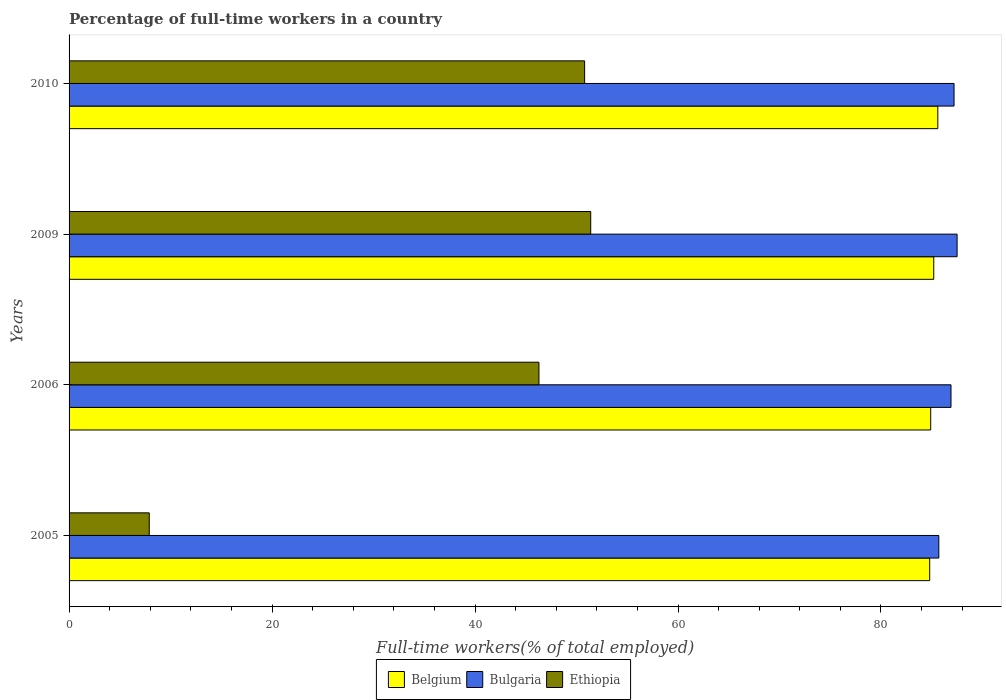Are the number of bars on each tick of the Y-axis equal?
Provide a succinct answer. Yes. How many bars are there on the 4th tick from the top?
Offer a very short reply. 3. What is the label of the 4th group of bars from the top?
Ensure brevity in your answer.  2005. What is the percentage of full-time workers in Bulgaria in 2009?
Your answer should be very brief. 87.5. Across all years, what is the maximum percentage of full-time workers in Ethiopia?
Offer a very short reply. 51.4. Across all years, what is the minimum percentage of full-time workers in Belgium?
Offer a terse response. 84.8. What is the total percentage of full-time workers in Belgium in the graph?
Offer a very short reply. 340.5. What is the difference between the percentage of full-time workers in Bulgaria in 2005 and that in 2006?
Ensure brevity in your answer.  -1.2. What is the difference between the percentage of full-time workers in Bulgaria in 2006 and the percentage of full-time workers in Ethiopia in 2005?
Provide a short and direct response. 79. What is the average percentage of full-time workers in Belgium per year?
Give a very brief answer. 85.12. In the year 2005, what is the difference between the percentage of full-time workers in Bulgaria and percentage of full-time workers in Ethiopia?
Provide a short and direct response. 77.8. What is the ratio of the percentage of full-time workers in Ethiopia in 2009 to that in 2010?
Provide a short and direct response. 1.01. Is the percentage of full-time workers in Ethiopia in 2005 less than that in 2006?
Offer a terse response. Yes. Is the difference between the percentage of full-time workers in Bulgaria in 2005 and 2010 greater than the difference between the percentage of full-time workers in Ethiopia in 2005 and 2010?
Give a very brief answer. Yes. What is the difference between the highest and the second highest percentage of full-time workers in Belgium?
Offer a very short reply. 0.4. What is the difference between the highest and the lowest percentage of full-time workers in Ethiopia?
Offer a very short reply. 43.5. In how many years, is the percentage of full-time workers in Bulgaria greater than the average percentage of full-time workers in Bulgaria taken over all years?
Ensure brevity in your answer.  3. Is the sum of the percentage of full-time workers in Ethiopia in 2005 and 2009 greater than the maximum percentage of full-time workers in Belgium across all years?
Offer a very short reply. No. What does the 2nd bar from the top in 2010 represents?
Your answer should be very brief. Bulgaria. What does the 3rd bar from the bottom in 2010 represents?
Ensure brevity in your answer.  Ethiopia. How many bars are there?
Your answer should be compact. 12. Are all the bars in the graph horizontal?
Provide a succinct answer. Yes. What is the difference between two consecutive major ticks on the X-axis?
Provide a short and direct response. 20. Where does the legend appear in the graph?
Offer a terse response. Bottom center. How are the legend labels stacked?
Your answer should be compact. Horizontal. What is the title of the graph?
Offer a very short reply. Percentage of full-time workers in a country. Does "European Union" appear as one of the legend labels in the graph?
Offer a very short reply. No. What is the label or title of the X-axis?
Provide a short and direct response. Full-time workers(% of total employed). What is the label or title of the Y-axis?
Make the answer very short. Years. What is the Full-time workers(% of total employed) in Belgium in 2005?
Keep it short and to the point. 84.8. What is the Full-time workers(% of total employed) in Bulgaria in 2005?
Provide a short and direct response. 85.7. What is the Full-time workers(% of total employed) of Ethiopia in 2005?
Provide a succinct answer. 7.9. What is the Full-time workers(% of total employed) in Belgium in 2006?
Ensure brevity in your answer.  84.9. What is the Full-time workers(% of total employed) in Bulgaria in 2006?
Offer a terse response. 86.9. What is the Full-time workers(% of total employed) of Ethiopia in 2006?
Provide a short and direct response. 46.3. What is the Full-time workers(% of total employed) of Belgium in 2009?
Offer a very short reply. 85.2. What is the Full-time workers(% of total employed) of Bulgaria in 2009?
Offer a very short reply. 87.5. What is the Full-time workers(% of total employed) in Ethiopia in 2009?
Your response must be concise. 51.4. What is the Full-time workers(% of total employed) of Belgium in 2010?
Offer a very short reply. 85.6. What is the Full-time workers(% of total employed) of Bulgaria in 2010?
Your response must be concise. 87.2. What is the Full-time workers(% of total employed) in Ethiopia in 2010?
Keep it short and to the point. 50.8. Across all years, what is the maximum Full-time workers(% of total employed) in Belgium?
Offer a very short reply. 85.6. Across all years, what is the maximum Full-time workers(% of total employed) of Bulgaria?
Offer a terse response. 87.5. Across all years, what is the maximum Full-time workers(% of total employed) in Ethiopia?
Offer a very short reply. 51.4. Across all years, what is the minimum Full-time workers(% of total employed) of Belgium?
Provide a succinct answer. 84.8. Across all years, what is the minimum Full-time workers(% of total employed) of Bulgaria?
Ensure brevity in your answer.  85.7. Across all years, what is the minimum Full-time workers(% of total employed) in Ethiopia?
Offer a terse response. 7.9. What is the total Full-time workers(% of total employed) of Belgium in the graph?
Your answer should be very brief. 340.5. What is the total Full-time workers(% of total employed) of Bulgaria in the graph?
Your answer should be compact. 347.3. What is the total Full-time workers(% of total employed) of Ethiopia in the graph?
Give a very brief answer. 156.4. What is the difference between the Full-time workers(% of total employed) of Ethiopia in 2005 and that in 2006?
Provide a short and direct response. -38.4. What is the difference between the Full-time workers(% of total employed) in Belgium in 2005 and that in 2009?
Make the answer very short. -0.4. What is the difference between the Full-time workers(% of total employed) of Ethiopia in 2005 and that in 2009?
Your answer should be very brief. -43.5. What is the difference between the Full-time workers(% of total employed) in Bulgaria in 2005 and that in 2010?
Your response must be concise. -1.5. What is the difference between the Full-time workers(% of total employed) in Ethiopia in 2005 and that in 2010?
Ensure brevity in your answer.  -42.9. What is the difference between the Full-time workers(% of total employed) in Belgium in 2009 and that in 2010?
Make the answer very short. -0.4. What is the difference between the Full-time workers(% of total employed) in Ethiopia in 2009 and that in 2010?
Offer a very short reply. 0.6. What is the difference between the Full-time workers(% of total employed) of Belgium in 2005 and the Full-time workers(% of total employed) of Bulgaria in 2006?
Your answer should be very brief. -2.1. What is the difference between the Full-time workers(% of total employed) in Belgium in 2005 and the Full-time workers(% of total employed) in Ethiopia in 2006?
Keep it short and to the point. 38.5. What is the difference between the Full-time workers(% of total employed) of Bulgaria in 2005 and the Full-time workers(% of total employed) of Ethiopia in 2006?
Provide a short and direct response. 39.4. What is the difference between the Full-time workers(% of total employed) of Belgium in 2005 and the Full-time workers(% of total employed) of Bulgaria in 2009?
Your response must be concise. -2.7. What is the difference between the Full-time workers(% of total employed) of Belgium in 2005 and the Full-time workers(% of total employed) of Ethiopia in 2009?
Provide a succinct answer. 33.4. What is the difference between the Full-time workers(% of total employed) in Bulgaria in 2005 and the Full-time workers(% of total employed) in Ethiopia in 2009?
Your answer should be compact. 34.3. What is the difference between the Full-time workers(% of total employed) of Belgium in 2005 and the Full-time workers(% of total employed) of Ethiopia in 2010?
Keep it short and to the point. 34. What is the difference between the Full-time workers(% of total employed) in Bulgaria in 2005 and the Full-time workers(% of total employed) in Ethiopia in 2010?
Offer a very short reply. 34.9. What is the difference between the Full-time workers(% of total employed) in Belgium in 2006 and the Full-time workers(% of total employed) in Ethiopia in 2009?
Your response must be concise. 33.5. What is the difference between the Full-time workers(% of total employed) in Bulgaria in 2006 and the Full-time workers(% of total employed) in Ethiopia in 2009?
Make the answer very short. 35.5. What is the difference between the Full-time workers(% of total employed) of Belgium in 2006 and the Full-time workers(% of total employed) of Bulgaria in 2010?
Keep it short and to the point. -2.3. What is the difference between the Full-time workers(% of total employed) of Belgium in 2006 and the Full-time workers(% of total employed) of Ethiopia in 2010?
Give a very brief answer. 34.1. What is the difference between the Full-time workers(% of total employed) in Bulgaria in 2006 and the Full-time workers(% of total employed) in Ethiopia in 2010?
Your answer should be compact. 36.1. What is the difference between the Full-time workers(% of total employed) of Belgium in 2009 and the Full-time workers(% of total employed) of Ethiopia in 2010?
Provide a short and direct response. 34.4. What is the difference between the Full-time workers(% of total employed) of Bulgaria in 2009 and the Full-time workers(% of total employed) of Ethiopia in 2010?
Offer a very short reply. 36.7. What is the average Full-time workers(% of total employed) of Belgium per year?
Your answer should be compact. 85.12. What is the average Full-time workers(% of total employed) in Bulgaria per year?
Give a very brief answer. 86.83. What is the average Full-time workers(% of total employed) of Ethiopia per year?
Your answer should be very brief. 39.1. In the year 2005, what is the difference between the Full-time workers(% of total employed) in Belgium and Full-time workers(% of total employed) in Ethiopia?
Offer a terse response. 76.9. In the year 2005, what is the difference between the Full-time workers(% of total employed) of Bulgaria and Full-time workers(% of total employed) of Ethiopia?
Your answer should be compact. 77.8. In the year 2006, what is the difference between the Full-time workers(% of total employed) of Belgium and Full-time workers(% of total employed) of Bulgaria?
Ensure brevity in your answer.  -2. In the year 2006, what is the difference between the Full-time workers(% of total employed) of Belgium and Full-time workers(% of total employed) of Ethiopia?
Your response must be concise. 38.6. In the year 2006, what is the difference between the Full-time workers(% of total employed) in Bulgaria and Full-time workers(% of total employed) in Ethiopia?
Provide a short and direct response. 40.6. In the year 2009, what is the difference between the Full-time workers(% of total employed) in Belgium and Full-time workers(% of total employed) in Ethiopia?
Make the answer very short. 33.8. In the year 2009, what is the difference between the Full-time workers(% of total employed) in Bulgaria and Full-time workers(% of total employed) in Ethiopia?
Offer a very short reply. 36.1. In the year 2010, what is the difference between the Full-time workers(% of total employed) in Belgium and Full-time workers(% of total employed) in Bulgaria?
Keep it short and to the point. -1.6. In the year 2010, what is the difference between the Full-time workers(% of total employed) in Belgium and Full-time workers(% of total employed) in Ethiopia?
Offer a very short reply. 34.8. In the year 2010, what is the difference between the Full-time workers(% of total employed) in Bulgaria and Full-time workers(% of total employed) in Ethiopia?
Give a very brief answer. 36.4. What is the ratio of the Full-time workers(% of total employed) in Belgium in 2005 to that in 2006?
Your answer should be very brief. 1. What is the ratio of the Full-time workers(% of total employed) of Bulgaria in 2005 to that in 2006?
Your answer should be very brief. 0.99. What is the ratio of the Full-time workers(% of total employed) in Ethiopia in 2005 to that in 2006?
Ensure brevity in your answer.  0.17. What is the ratio of the Full-time workers(% of total employed) of Bulgaria in 2005 to that in 2009?
Offer a terse response. 0.98. What is the ratio of the Full-time workers(% of total employed) in Ethiopia in 2005 to that in 2009?
Make the answer very short. 0.15. What is the ratio of the Full-time workers(% of total employed) of Bulgaria in 2005 to that in 2010?
Your answer should be compact. 0.98. What is the ratio of the Full-time workers(% of total employed) of Ethiopia in 2005 to that in 2010?
Your response must be concise. 0.16. What is the ratio of the Full-time workers(% of total employed) in Belgium in 2006 to that in 2009?
Make the answer very short. 1. What is the ratio of the Full-time workers(% of total employed) of Bulgaria in 2006 to that in 2009?
Keep it short and to the point. 0.99. What is the ratio of the Full-time workers(% of total employed) in Ethiopia in 2006 to that in 2009?
Your answer should be compact. 0.9. What is the ratio of the Full-time workers(% of total employed) of Belgium in 2006 to that in 2010?
Ensure brevity in your answer.  0.99. What is the ratio of the Full-time workers(% of total employed) of Bulgaria in 2006 to that in 2010?
Offer a very short reply. 1. What is the ratio of the Full-time workers(% of total employed) of Ethiopia in 2006 to that in 2010?
Ensure brevity in your answer.  0.91. What is the ratio of the Full-time workers(% of total employed) in Ethiopia in 2009 to that in 2010?
Offer a very short reply. 1.01. What is the difference between the highest and the second highest Full-time workers(% of total employed) of Ethiopia?
Offer a terse response. 0.6. What is the difference between the highest and the lowest Full-time workers(% of total employed) of Belgium?
Make the answer very short. 0.8. What is the difference between the highest and the lowest Full-time workers(% of total employed) in Ethiopia?
Give a very brief answer. 43.5. 